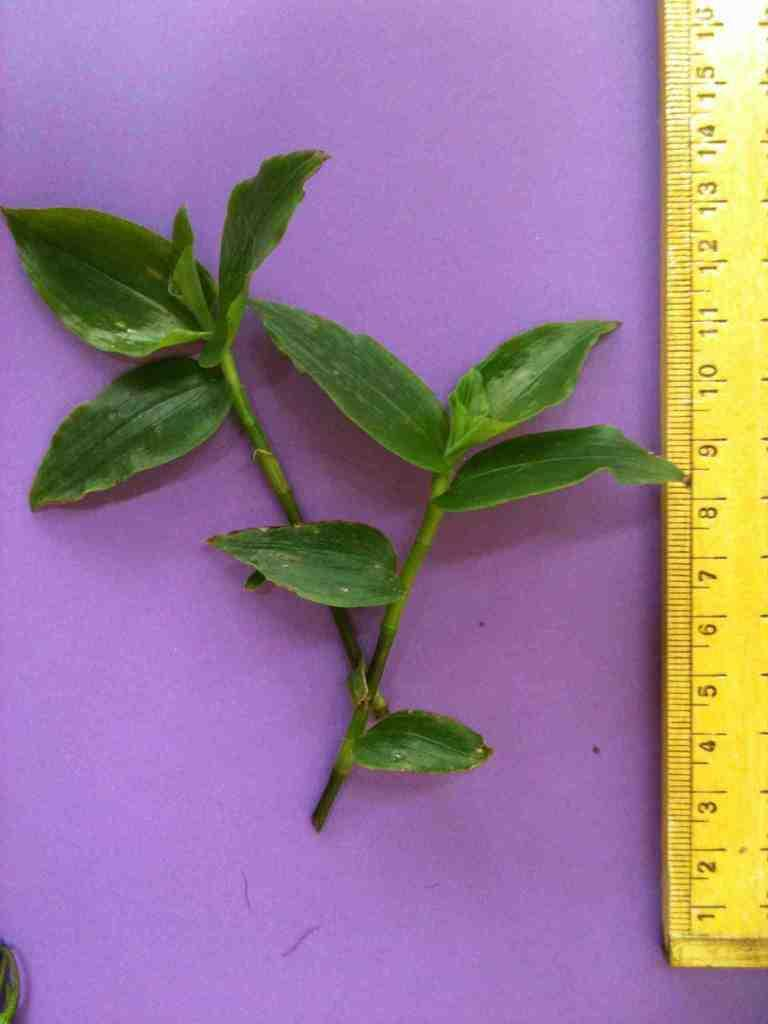What type of living organisms can be seen in the image? Plants can be seen in the image. What object is located on the right side of the image? There is a scale on the right side of the image. How many cows are visible in the image? There are no cows present in the image. What type of nut can be seen on the plants in the image? There is no nut visible on the plants in the image. 